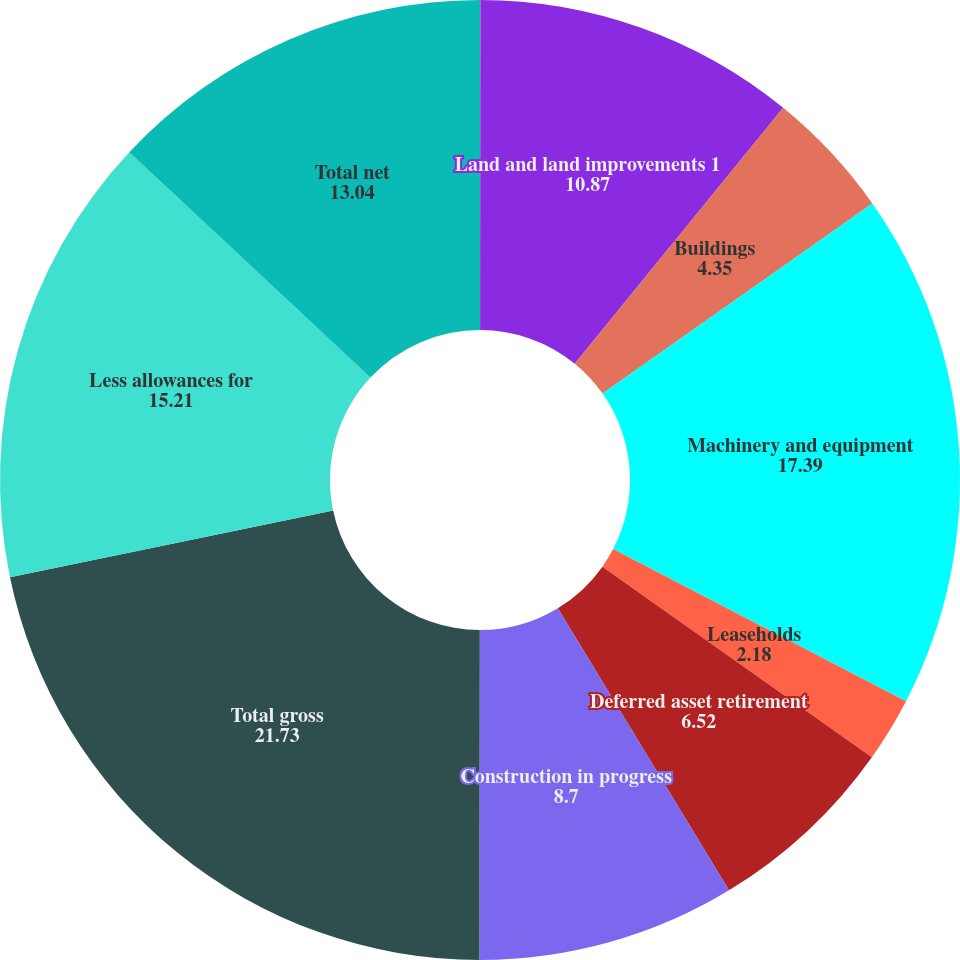Convert chart to OTSL. <chart><loc_0><loc_0><loc_500><loc_500><pie_chart><fcel>in thousands<fcel>Land and land improvements 1<fcel>Buildings<fcel>Machinery and equipment<fcel>Leaseholds<fcel>Deferred asset retirement<fcel>Construction in progress<fcel>Total gross<fcel>Less allowances for<fcel>Total net<nl><fcel>0.01%<fcel>10.87%<fcel>4.35%<fcel>17.39%<fcel>2.18%<fcel>6.52%<fcel>8.7%<fcel>21.73%<fcel>15.21%<fcel>13.04%<nl></chart> 